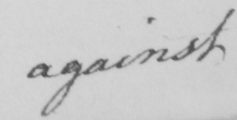Can you read and transcribe this handwriting? against 